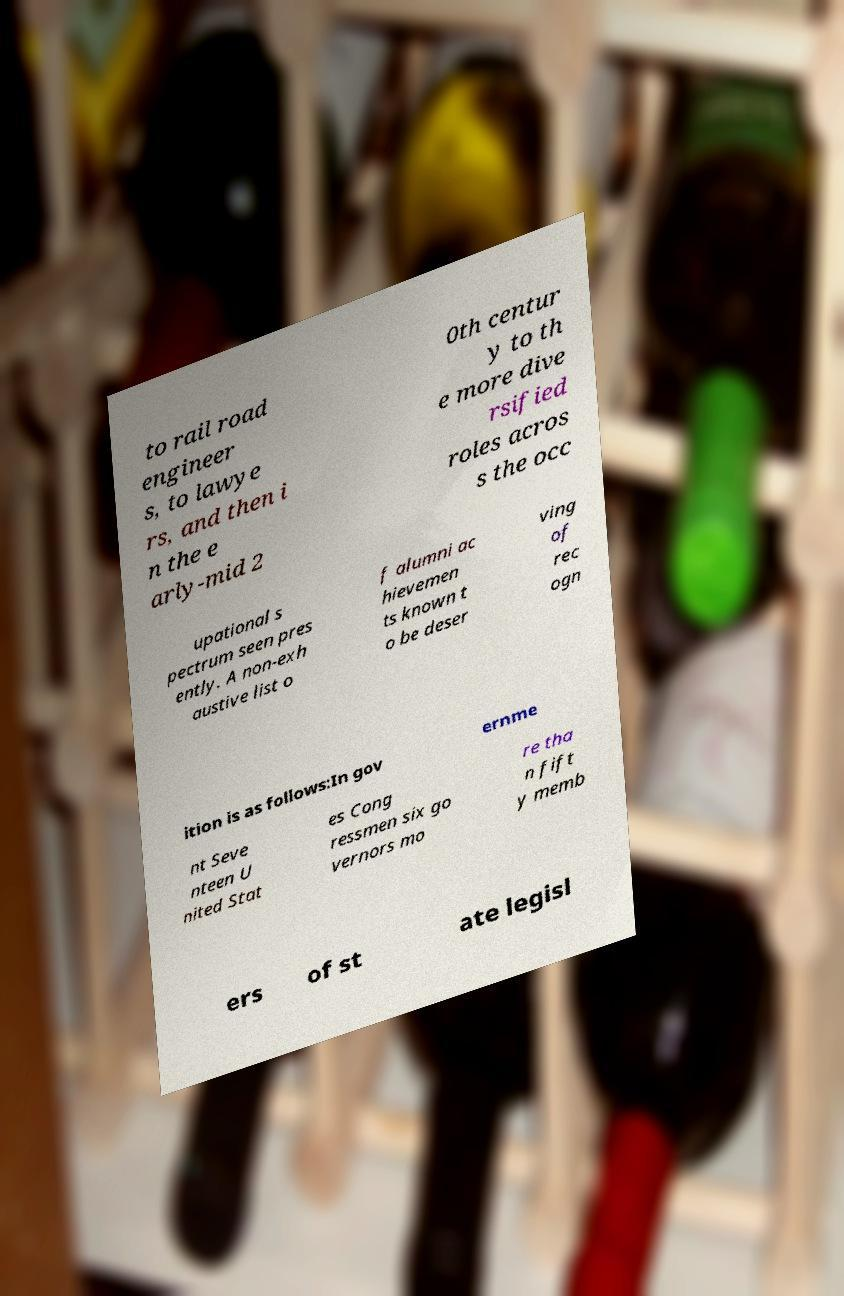Can you read and provide the text displayed in the image?This photo seems to have some interesting text. Can you extract and type it out for me? to rail road engineer s, to lawye rs, and then i n the e arly-mid 2 0th centur y to th e more dive rsified roles acros s the occ upational s pectrum seen pres ently. A non-exh austive list o f alumni ac hievemen ts known t o be deser ving of rec ogn ition is as follows:In gov ernme nt Seve nteen U nited Stat es Cong ressmen six go vernors mo re tha n fift y memb ers of st ate legisl 